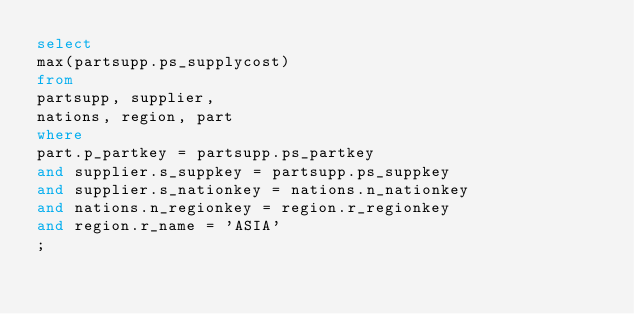Convert code to text. <code><loc_0><loc_0><loc_500><loc_500><_SQL_>select
max(partsupp.ps_supplycost)
from
partsupp, supplier,
nations, region, part
where
part.p_partkey = partsupp.ps_partkey
and supplier.s_suppkey = partsupp.ps_suppkey
and supplier.s_nationkey = nations.n_nationkey
and nations.n_regionkey = region.r_regionkey
and region.r_name = 'ASIA'
;
</code> 